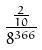<formula> <loc_0><loc_0><loc_500><loc_500>\frac { \frac { 2 } { 1 0 } } { 8 ^ { 3 6 6 } }</formula> 